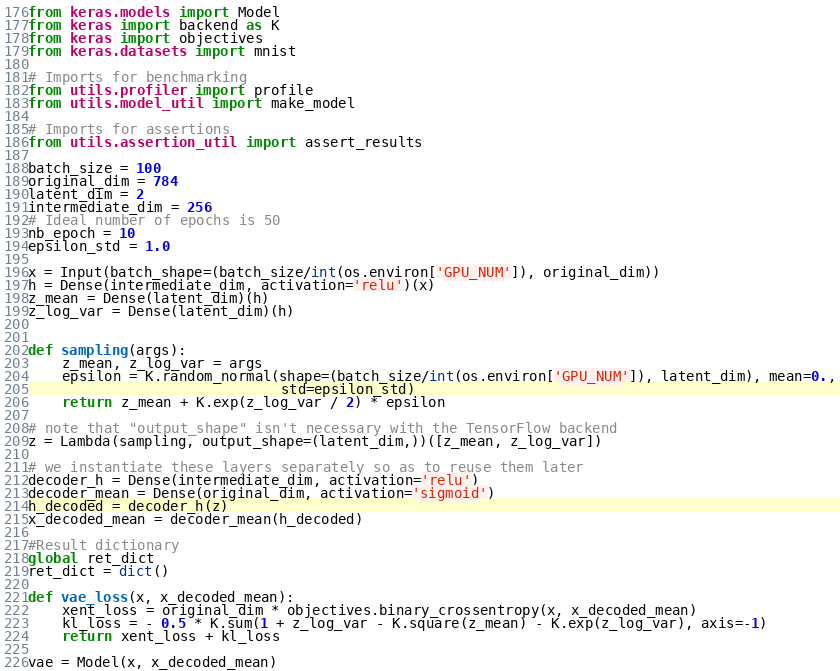Convert code to text. <code><loc_0><loc_0><loc_500><loc_500><_Python_>from keras.models import Model
from keras import backend as K
from keras import objectives
from keras.datasets import mnist

# Imports for benchmarking
from utils.profiler import profile
from utils.model_util import make_model

# Imports for assertions
from utils.assertion_util import assert_results

batch_size = 100
original_dim = 784
latent_dim = 2
intermediate_dim = 256
# Ideal number of epochs is 50
nb_epoch = 10
epsilon_std = 1.0

x = Input(batch_shape=(batch_size/int(os.environ['GPU_NUM']), original_dim))
h = Dense(intermediate_dim, activation='relu')(x)
z_mean = Dense(latent_dim)(h)
z_log_var = Dense(latent_dim)(h)


def sampling(args):
    z_mean, z_log_var = args
    epsilon = K.random_normal(shape=(batch_size/int(os.environ['GPU_NUM']), latent_dim), mean=0.,
                              std=epsilon_std)
    return z_mean + K.exp(z_log_var / 2) * epsilon

# note that "output_shape" isn't necessary with the TensorFlow backend
z = Lambda(sampling, output_shape=(latent_dim,))([z_mean, z_log_var])

# we instantiate these layers separately so as to reuse them later
decoder_h = Dense(intermediate_dim, activation='relu')
decoder_mean = Dense(original_dim, activation='sigmoid')
h_decoded = decoder_h(z)
x_decoded_mean = decoder_mean(h_decoded)

#Result dictionary
global ret_dict
ret_dict = dict()

def vae_loss(x, x_decoded_mean):
    xent_loss = original_dim * objectives.binary_crossentropy(x, x_decoded_mean)
    kl_loss = - 0.5 * K.sum(1 + z_log_var - K.square(z_mean) - K.exp(z_log_var), axis=-1)
    return xent_loss + kl_loss

vae = Model(x, x_decoded_mean)</code> 